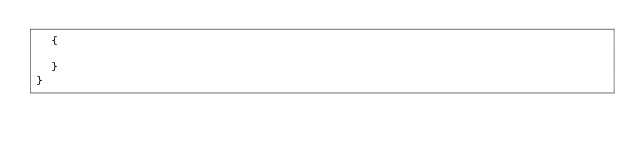Convert code to text. <code><loc_0><loc_0><loc_500><loc_500><_C#_>	{

	}
}
</code> 